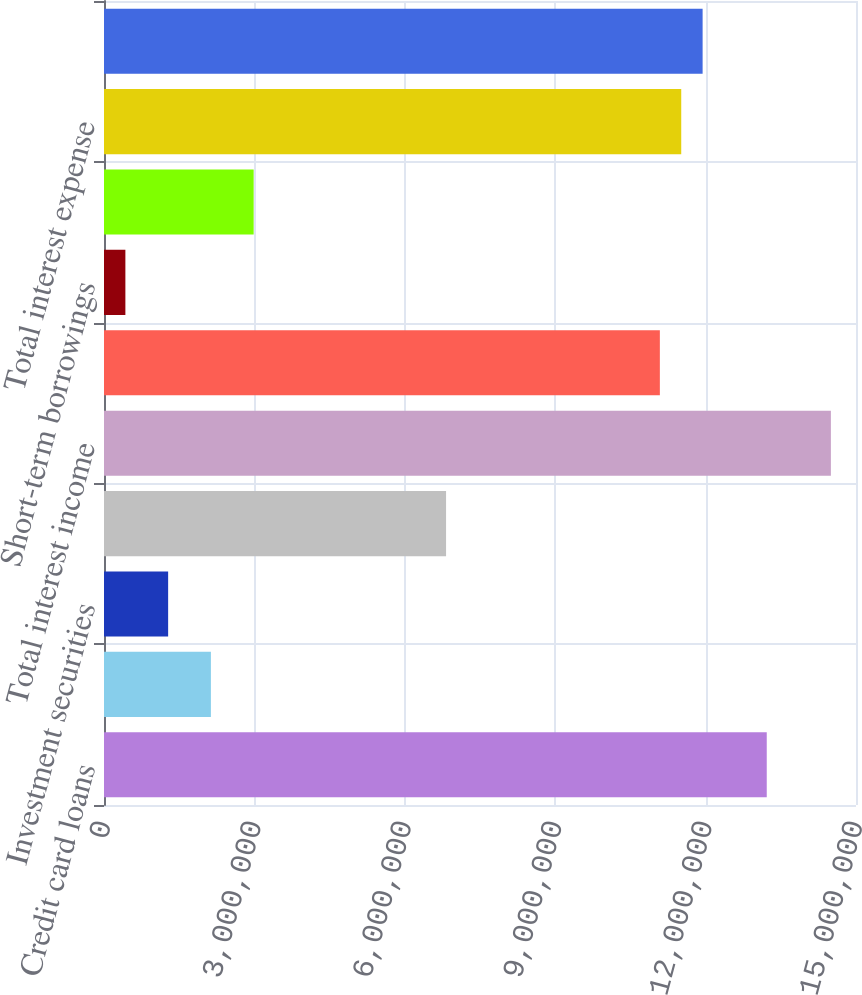<chart> <loc_0><loc_0><loc_500><loc_500><bar_chart><fcel>Credit card loans<fcel>Other loans<fcel>Investment securities<fcel>Other interest income<fcel>Total interest income<fcel>Deposits<fcel>Short-term borrowings<fcel>Long-term borrowings<fcel>Total interest expense<fcel>Net interest income<nl><fcel>1.32198e+07<fcel>2.13223e+06<fcel>1.27934e+06<fcel>6.82313e+06<fcel>1.44992e+07<fcel>1.10876e+07<fcel>426446<fcel>2.98512e+06<fcel>1.1514e+07<fcel>1.19405e+07<nl></chart> 